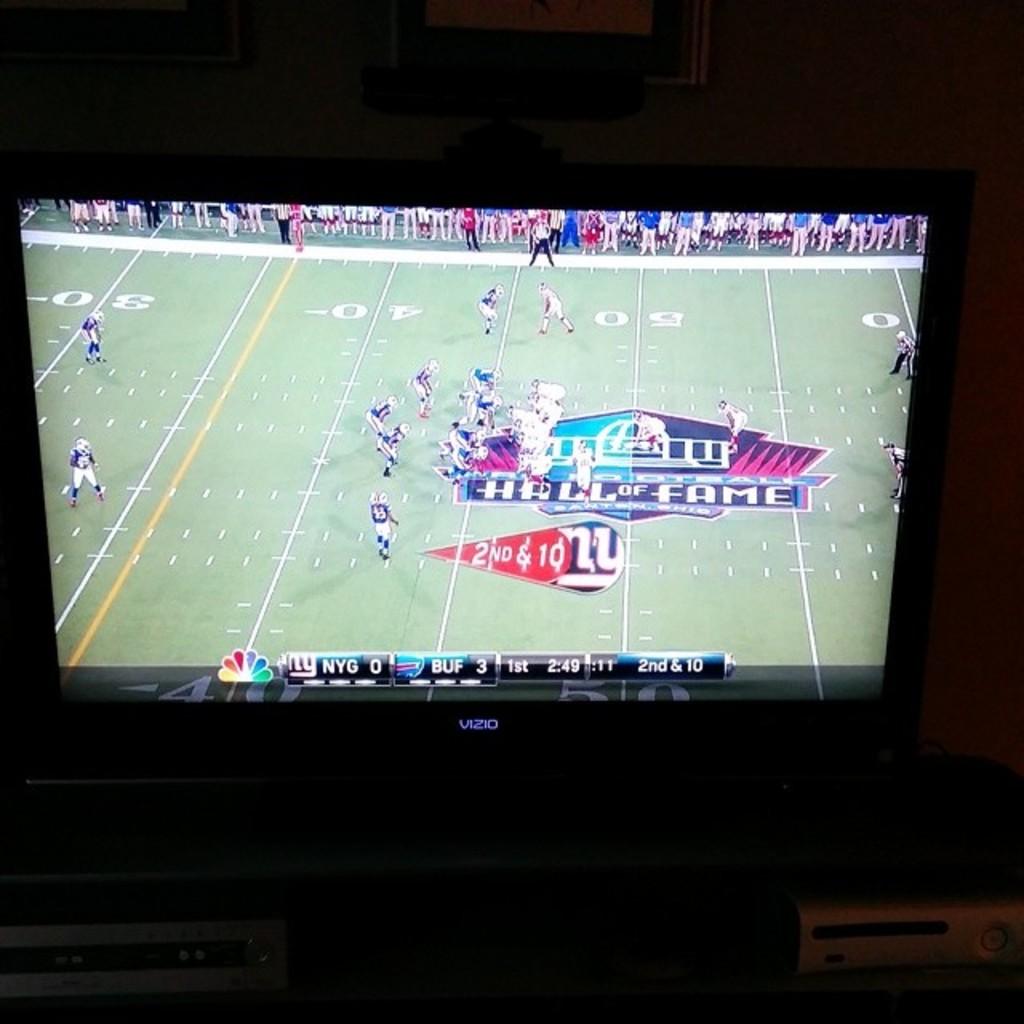Which team is leading?
Keep it short and to the point. Buf. What's the score?
Offer a terse response. 0-3. 